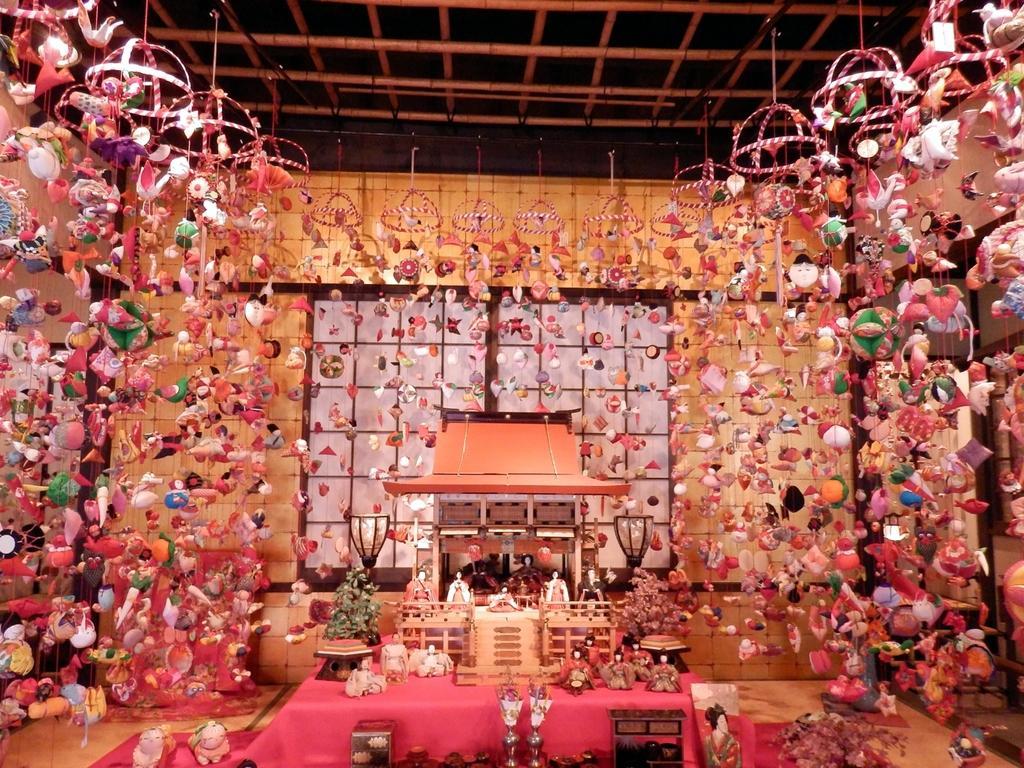Could you give a brief overview of what you see in this image? In this image there are toys. In the center there is a table and on the table there are toys. In the background there is a window and there are toys hanging. 